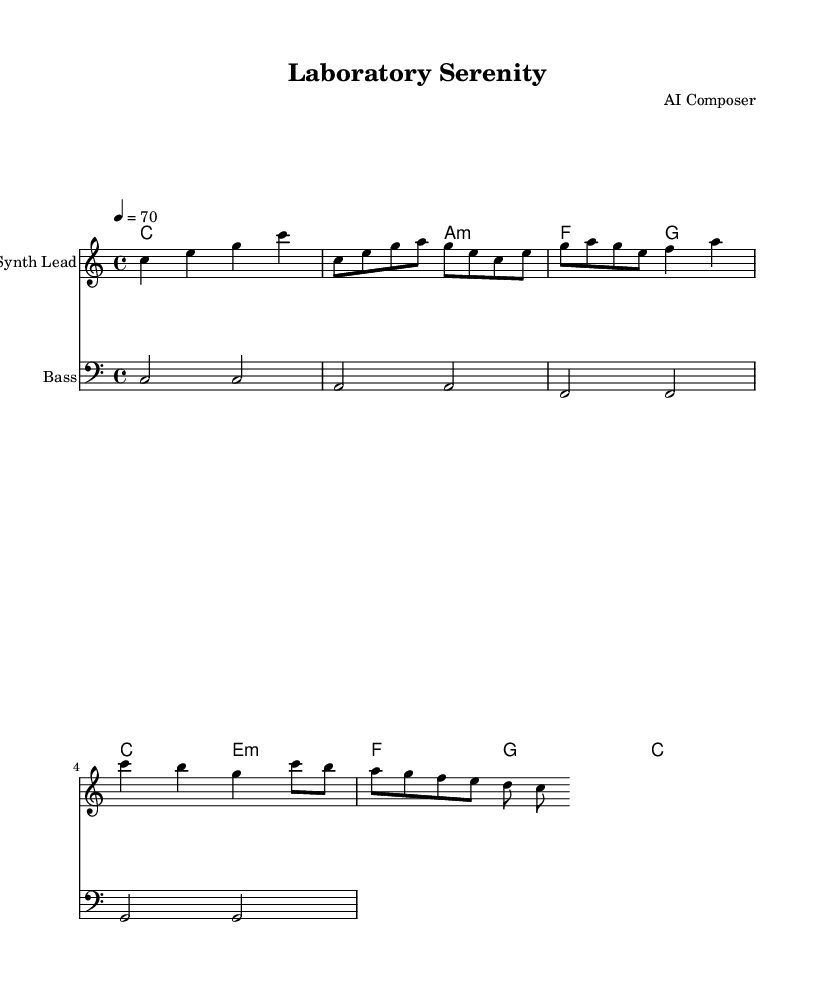What is the key signature of this music? The key signature displayed in the music sheet is C major, which indicates there are no sharps or flats. You can identify the key signature by looking at the beginning of the first staff.
Answer: C major What is the time signature of this music? The time signature is indicated as 4/4, meaning there are four beats per measure and the quarter note gets one beat. This can be found at the beginning of the score beneath the key signature.
Answer: 4/4 What is the tempo marking for this score? The tempo marking is indicated as '4 = 70,' meaning that the metronome should be set to 70 beats per minute with a quarter note receiving one beat. This is typically found at the start of the music score.
Answer: 70 How many measures are in the chorus section? The chorus section consists of one measure, as indicated by the notation in the score that specifies the rhythm and note progression, which can be counted from the written measures.
Answer: 1 What is the main type of instrument used for the melody in this piece? The score indicates that the melody is played on a synthesizer, as noted by the "Synth Lead" label on the staff containing the melody. This informs us about the instrument type connected with that specific part of the score.
Answer: Synth Lead What chords are used in the bridge section? The chords in the bridge are e minor and G major, which can be identified by examining the chord names below the staff for the bridge measures, allowing one to determine the harmonic progression.
Answer: e minor, G major Which section of the piece follows the verse? The section that follows the verse is the bridge, which can be deduced from the layout of the music where the verse ends and the bridge begins, marking a transition in the structure.
Answer: Bridge 